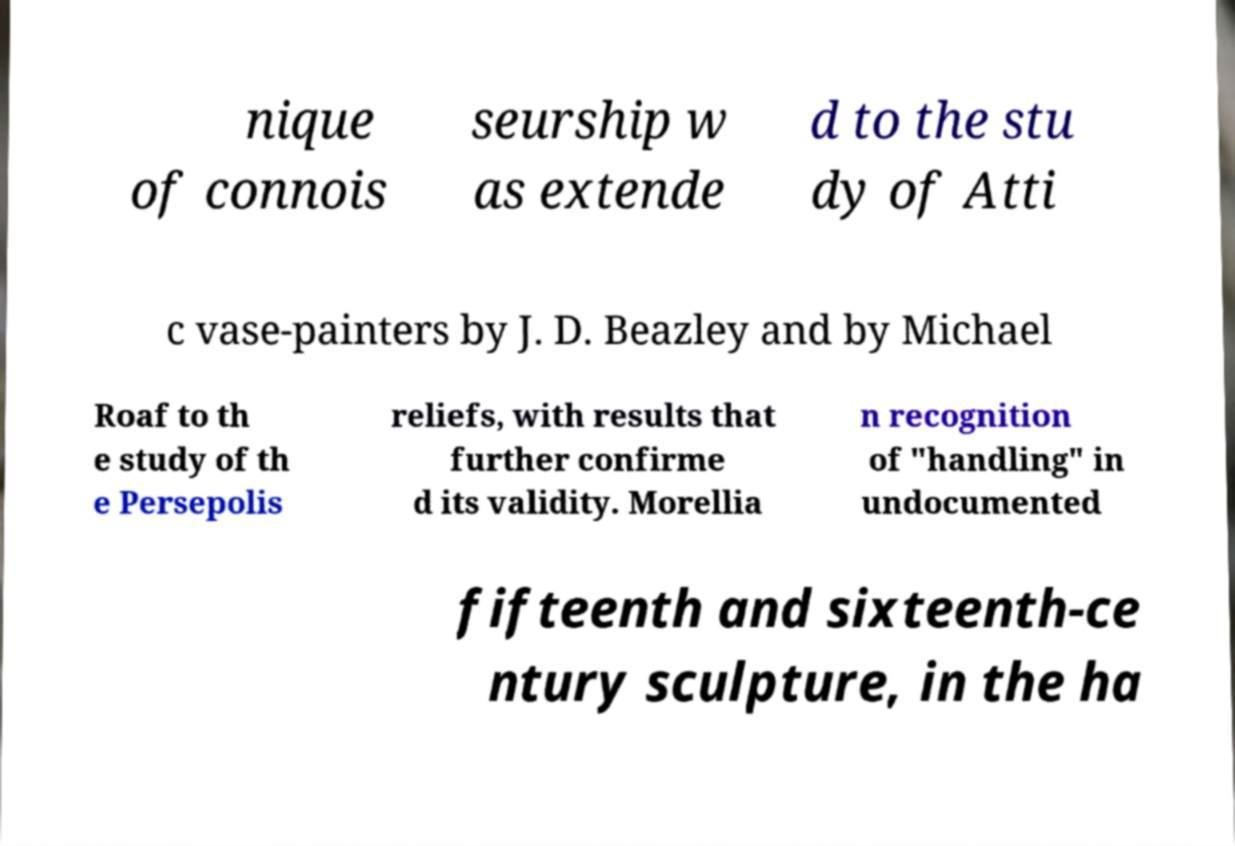Please read and relay the text visible in this image. What does it say? nique of connois seurship w as extende d to the stu dy of Atti c vase-painters by J. D. Beazley and by Michael Roaf to th e study of th e Persepolis reliefs, with results that further confirme d its validity. Morellia n recognition of "handling" in undocumented fifteenth and sixteenth-ce ntury sculpture, in the ha 